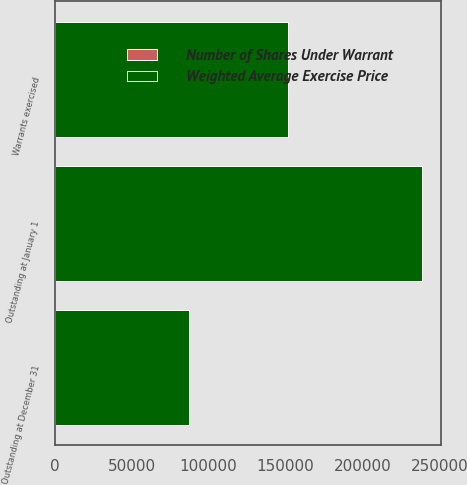Convert chart to OTSL. <chart><loc_0><loc_0><loc_500><loc_500><stacked_bar_chart><ecel><fcel>Outstanding at January 1<fcel>Warrants exercised<fcel>Outstanding at December 31<nl><fcel>Weighted Average Exercise Price<fcel>238703<fcel>151554<fcel>87149<nl><fcel>Number of Shares Under Warrant<fcel>16.24<fcel>17.96<fcel>13.24<nl></chart> 